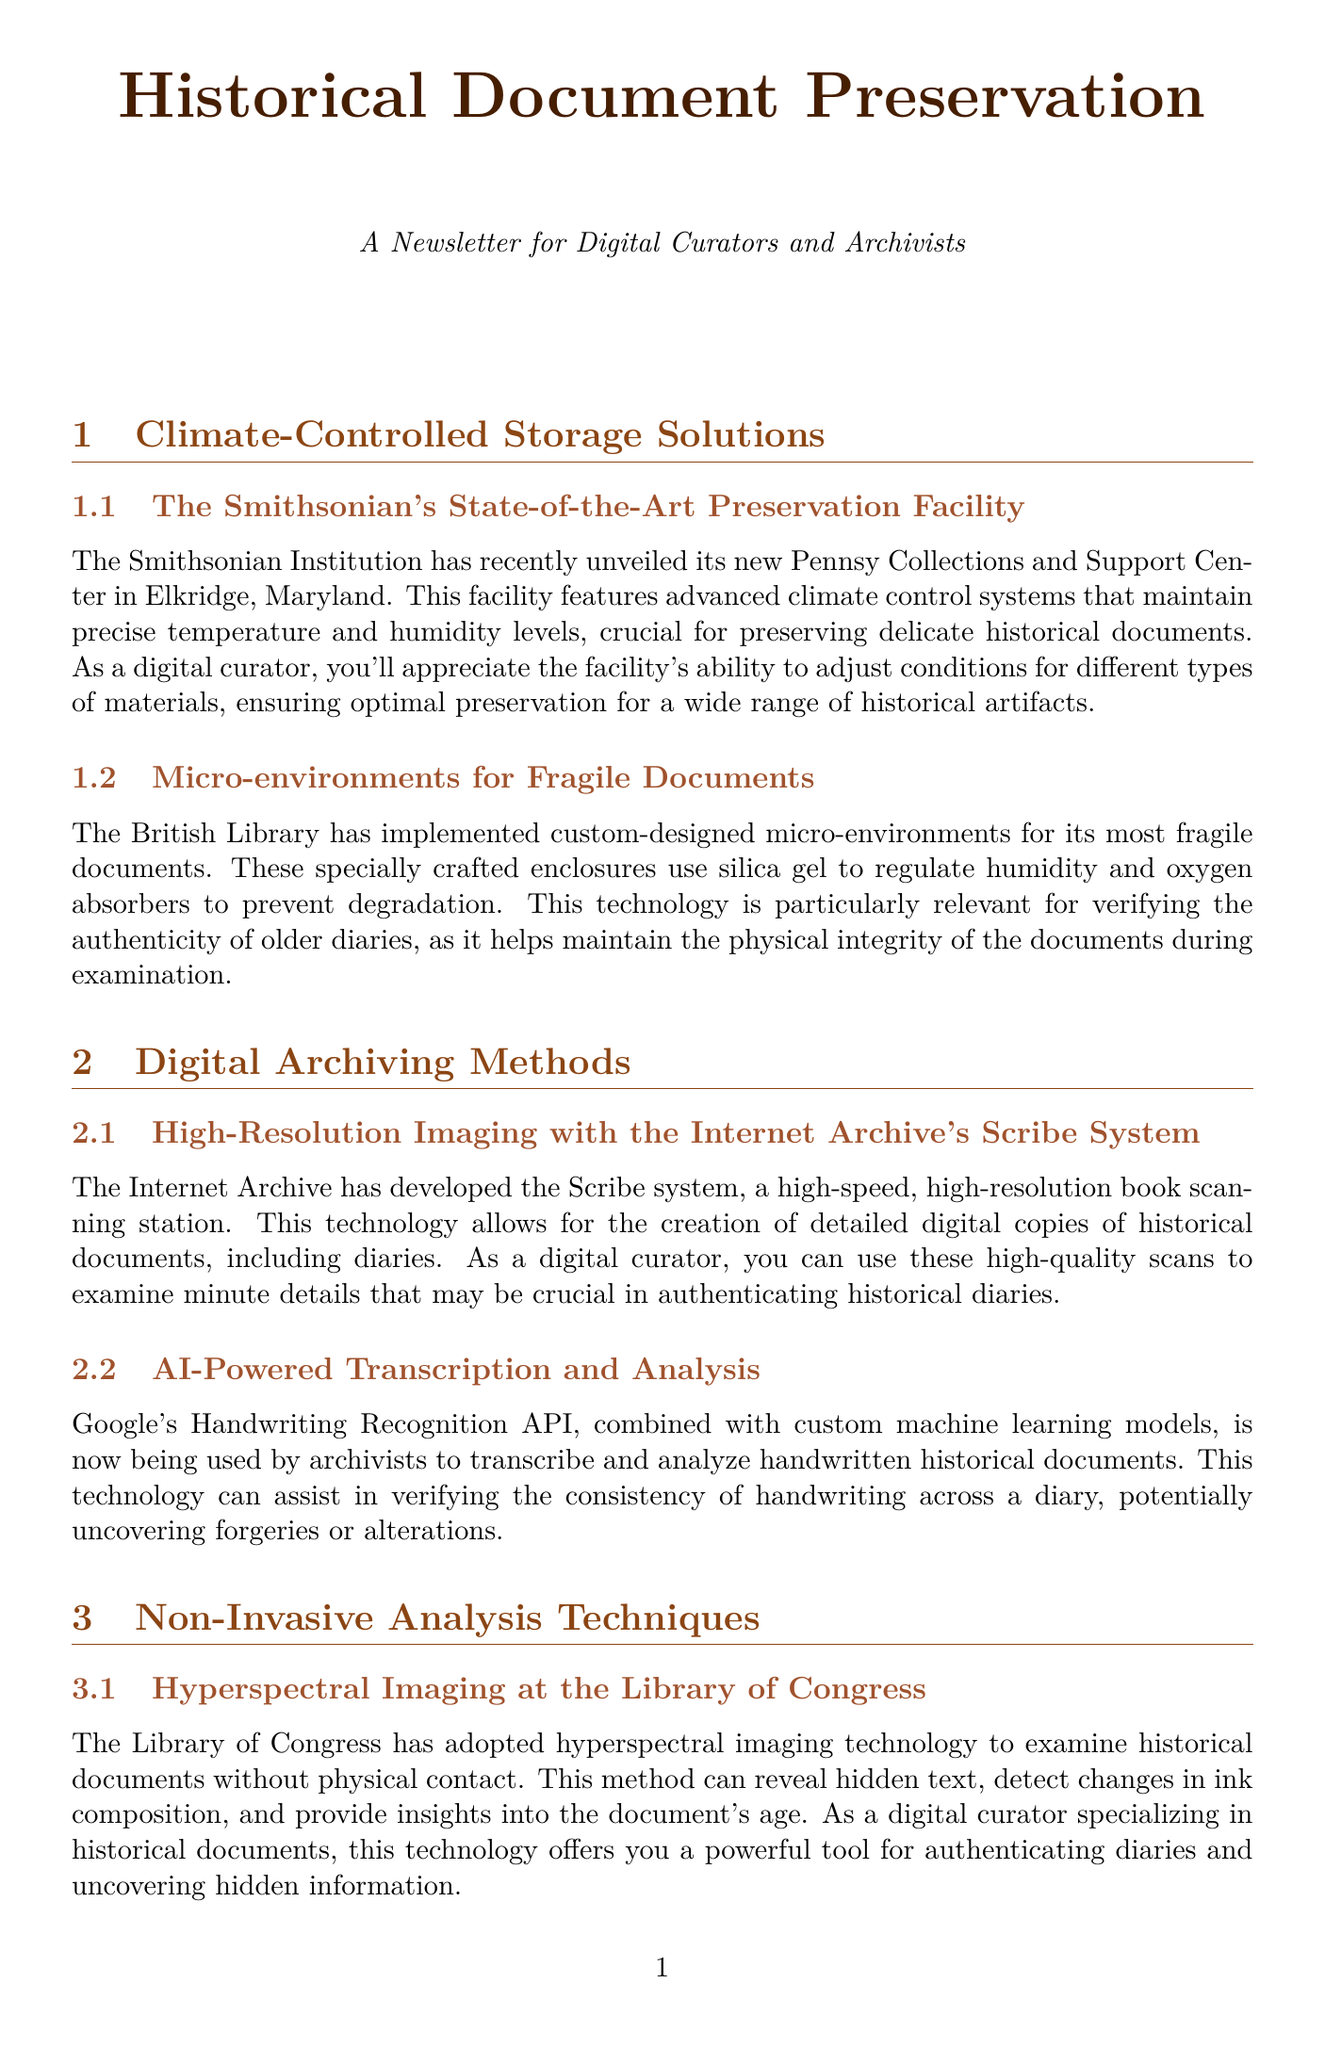What is the name of the new preservation facility unveiled by the Smithsonian Institution? The document mentions the Pennsy Collections and Support Center as the new facility.
Answer: Pennsy Collections and Support Center Which technology does the British Library use to regulate humidity for fragile documents? The document states that the British Library uses silica gel to regulate humidity.
Answer: Silica gel What is the purpose of the Internet Archive's Scribe system? The Scribe system is described as a high-speed, high-resolution book scanning station for creating digital copies of historical documents.
Answer: High-resolution book scanning What non-invasive technology does the Library of Congress employ? Hyperspectral imaging is identified as the technology used by the Library of Congress for examining documents without contact.
Answer: Hyperspectral imaging Which project utilizes blockchain technology for tracking document provenance? The ARCHANGEL project is mentioned as the initiative using blockchain to track provenance.
Answer: ARCHANGEL Project What method is utilized for handwriting transcription and analysis by Google? The Handwriting Recognition API is highlighted as the tool for transcribing handwritten documents.
Answer: Handwriting Recognition API How does X-ray fluorescence analysis assist in document verification? The document discusses that X-ray fluorescence analysis helps determine the age and origin of materials in historical documents.
Answer: Determine age and origin What specific type of micro-environment technology is highlighted by the British Library? The document notes that custom-designed micro-environments are used for fragile documents.
Answer: Micro-environments What additional verification does the ARCHANGEL project provide for historical diaries? The ARCHANGEL project provides an additional layer of verification through its tamper-proof record.
Answer: Tamper-proof record 